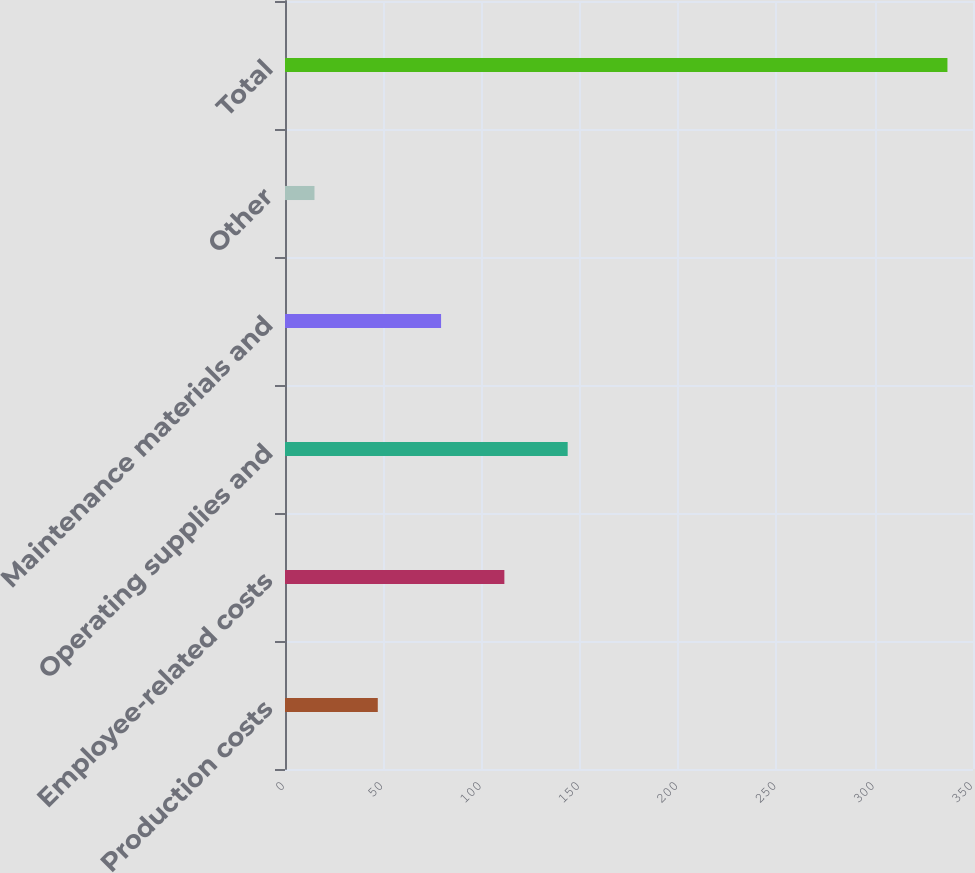Convert chart to OTSL. <chart><loc_0><loc_0><loc_500><loc_500><bar_chart><fcel>Production costs<fcel>Employee-related costs<fcel>Operating supplies and<fcel>Maintenance materials and<fcel>Other<fcel>Total<nl><fcel>47.2<fcel>111.6<fcel>143.8<fcel>79.4<fcel>15<fcel>337<nl></chart> 